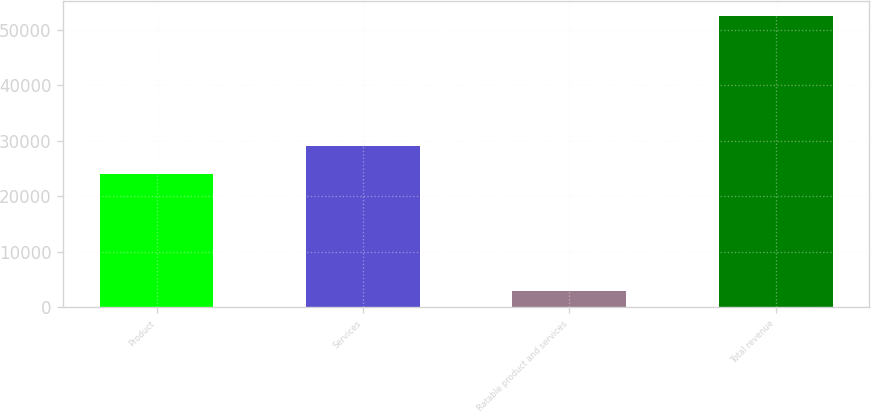Convert chart to OTSL. <chart><loc_0><loc_0><loc_500><loc_500><bar_chart><fcel>Product<fcel>Services<fcel>Ratable product and services<fcel>Total revenue<nl><fcel>24088<fcel>29042.3<fcel>3004<fcel>52547<nl></chart> 